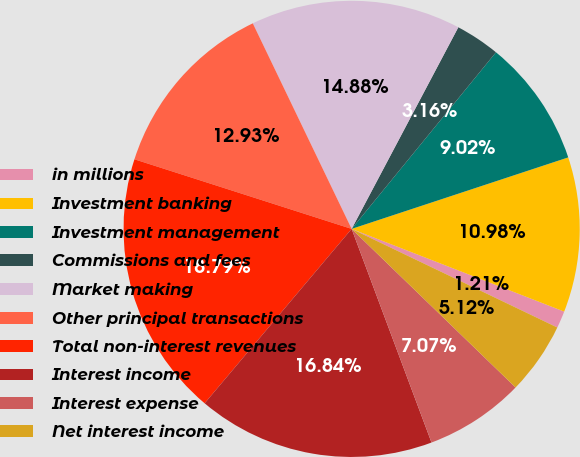<chart> <loc_0><loc_0><loc_500><loc_500><pie_chart><fcel>in millions<fcel>Investment banking<fcel>Investment management<fcel>Commissions and fees<fcel>Market making<fcel>Other principal transactions<fcel>Total non-interest revenues<fcel>Interest income<fcel>Interest expense<fcel>Net interest income<nl><fcel>1.21%<fcel>10.98%<fcel>9.02%<fcel>3.16%<fcel>14.88%<fcel>12.93%<fcel>18.79%<fcel>16.84%<fcel>7.07%<fcel>5.12%<nl></chart> 